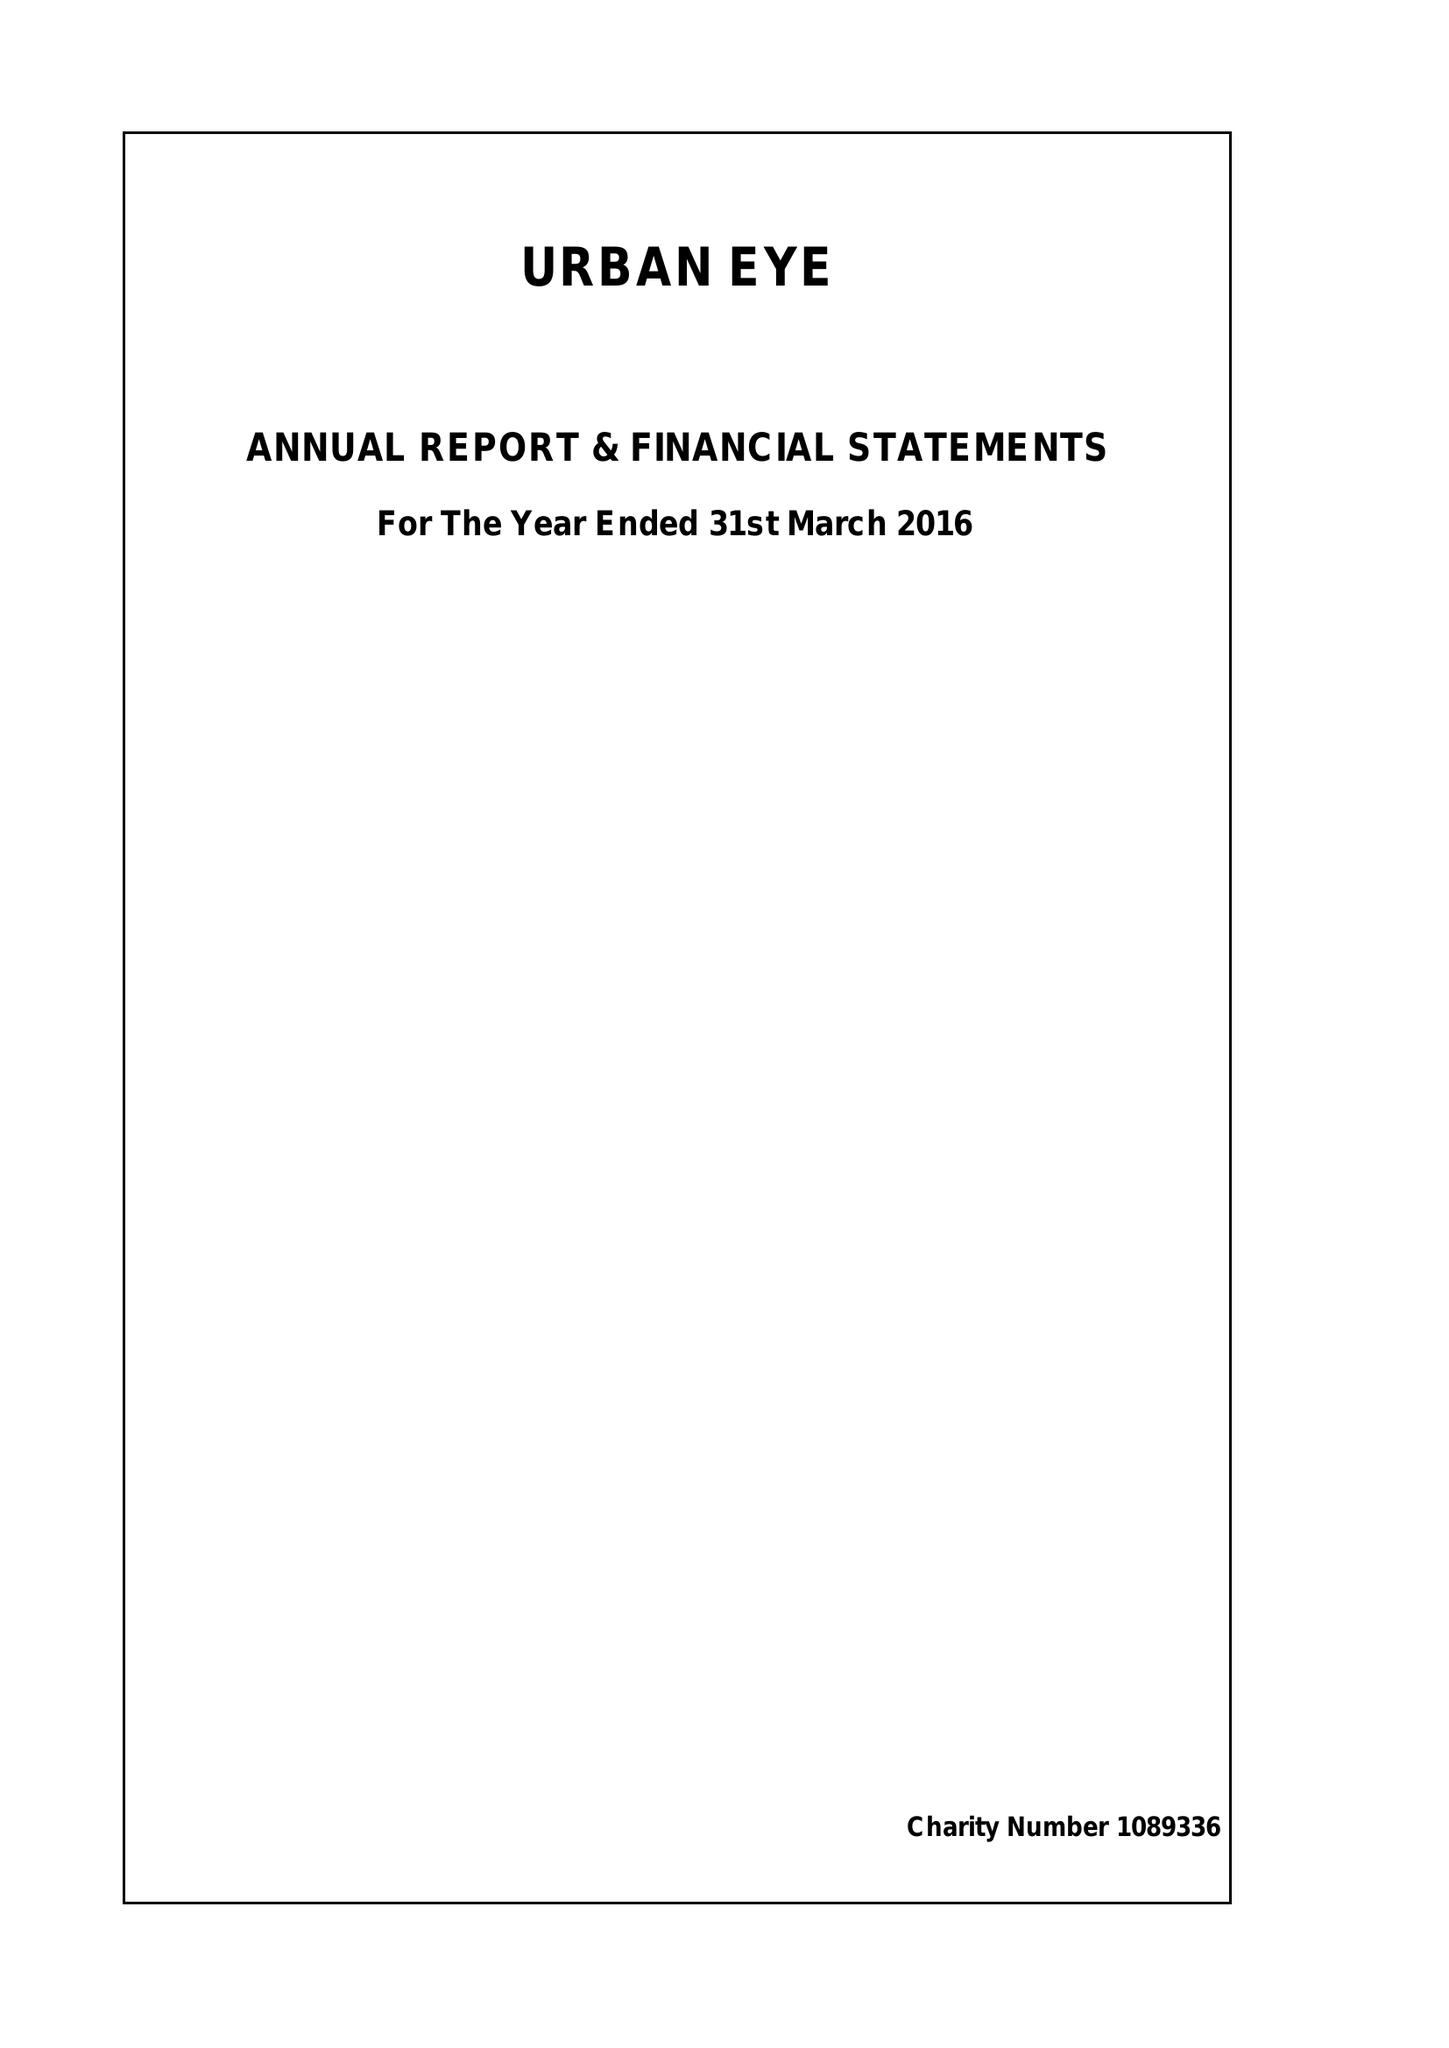What is the value for the income_annually_in_british_pounds?
Answer the question using a single word or phrase. 37350.00 